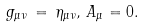Convert formula to latex. <formula><loc_0><loc_0><loc_500><loc_500>g _ { \mu \nu } \, = \, \eta _ { \mu \nu } , \, A _ { \mu } = 0 .</formula> 